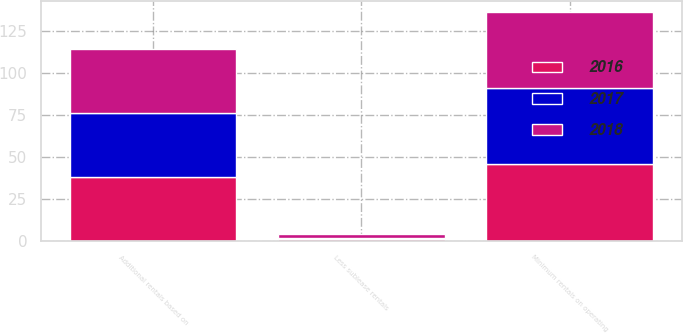<chart> <loc_0><loc_0><loc_500><loc_500><stacked_bar_chart><ecel><fcel>Minimum rentals on operating<fcel>Additional rentals based on<fcel>Less sublease rentals<nl><fcel>2017<fcel>45<fcel>38<fcel>1<nl><fcel>2016<fcel>46<fcel>38<fcel>1<nl><fcel>2018<fcel>45<fcel>38<fcel>2<nl></chart> 